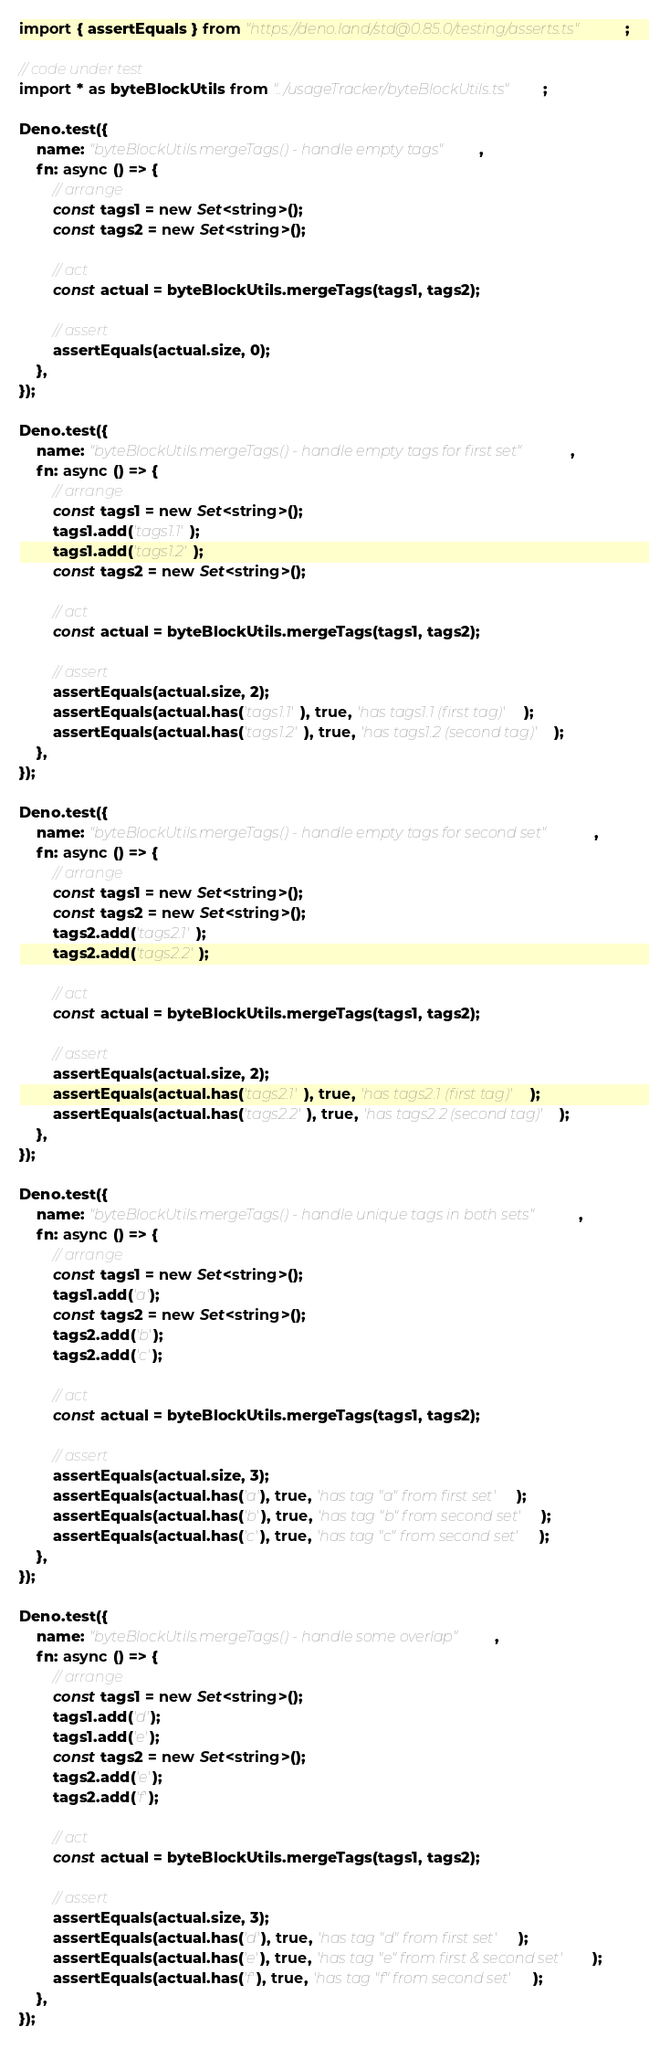Convert code to text. <code><loc_0><loc_0><loc_500><loc_500><_TypeScript_>import { assertEquals } from "https://deno.land/std@0.85.0/testing/asserts.ts";

// code under test
import * as byteBlockUtils from "../usageTracker/byteBlockUtils.ts";

Deno.test({
    name: "byteBlockUtils.mergeTags() - handle empty tags",
    fn: async () => {
        // arrange
        const tags1 = new Set<string>();
        const tags2 = new Set<string>();

        // act
        const actual = byteBlockUtils.mergeTags(tags1, tags2);

        // assert
        assertEquals(actual.size, 0);
    },
});

Deno.test({
    name: "byteBlockUtils.mergeTags() - handle empty tags for first set",
    fn: async () => {
        // arrange
        const tags1 = new Set<string>();
        tags1.add('tags1.1');
        tags1.add('tags1.2');
        const tags2 = new Set<string>();

        // act
        const actual = byteBlockUtils.mergeTags(tags1, tags2);

        // assert
        assertEquals(actual.size, 2);
        assertEquals(actual.has('tags1.1'), true, 'has tags1.1 (first tag)');
        assertEquals(actual.has('tags1.2'), true, 'has tags1.2 (second tag)');
    },
});

Deno.test({
    name: "byteBlockUtils.mergeTags() - handle empty tags for second set",
    fn: async () => {
        // arrange
        const tags1 = new Set<string>();
        const tags2 = new Set<string>();
        tags2.add('tags2.1');
        tags2.add('tags2.2');

        // act
        const actual = byteBlockUtils.mergeTags(tags1, tags2);

        // assert
        assertEquals(actual.size, 2);
        assertEquals(actual.has('tags2.1'), true, 'has tags2.1 (first tag)');
        assertEquals(actual.has('tags2.2'), true, 'has tags2.2 (second tag)');
    },
});

Deno.test({
    name: "byteBlockUtils.mergeTags() - handle unique tags in both sets",
    fn: async () => {
        // arrange
        const tags1 = new Set<string>();
        tags1.add('a');
        const tags2 = new Set<string>();
        tags2.add('b');
        tags2.add('c');

        // act
        const actual = byteBlockUtils.mergeTags(tags1, tags2);

        // assert
        assertEquals(actual.size, 3);
        assertEquals(actual.has('a'), true, 'has tag "a" from first set');
        assertEquals(actual.has('b'), true, 'has tag "b" from second set');
        assertEquals(actual.has('c'), true, 'has tag "c" from second set');
    },
});

Deno.test({
    name: "byteBlockUtils.mergeTags() - handle some overlap",
    fn: async () => {
        // arrange
        const tags1 = new Set<string>();
        tags1.add('d');
        tags1.add('e');
        const tags2 = new Set<string>();
        tags2.add('e');
        tags2.add('f');

        // act
        const actual = byteBlockUtils.mergeTags(tags1, tags2);

        // assert
        assertEquals(actual.size, 3);
        assertEquals(actual.has('d'), true, 'has tag "d" from first set');
        assertEquals(actual.has('e'), true, 'has tag "e" from first & second set');
        assertEquals(actual.has('f'), true, 'has tag "f" from second set');
    },
});

</code> 